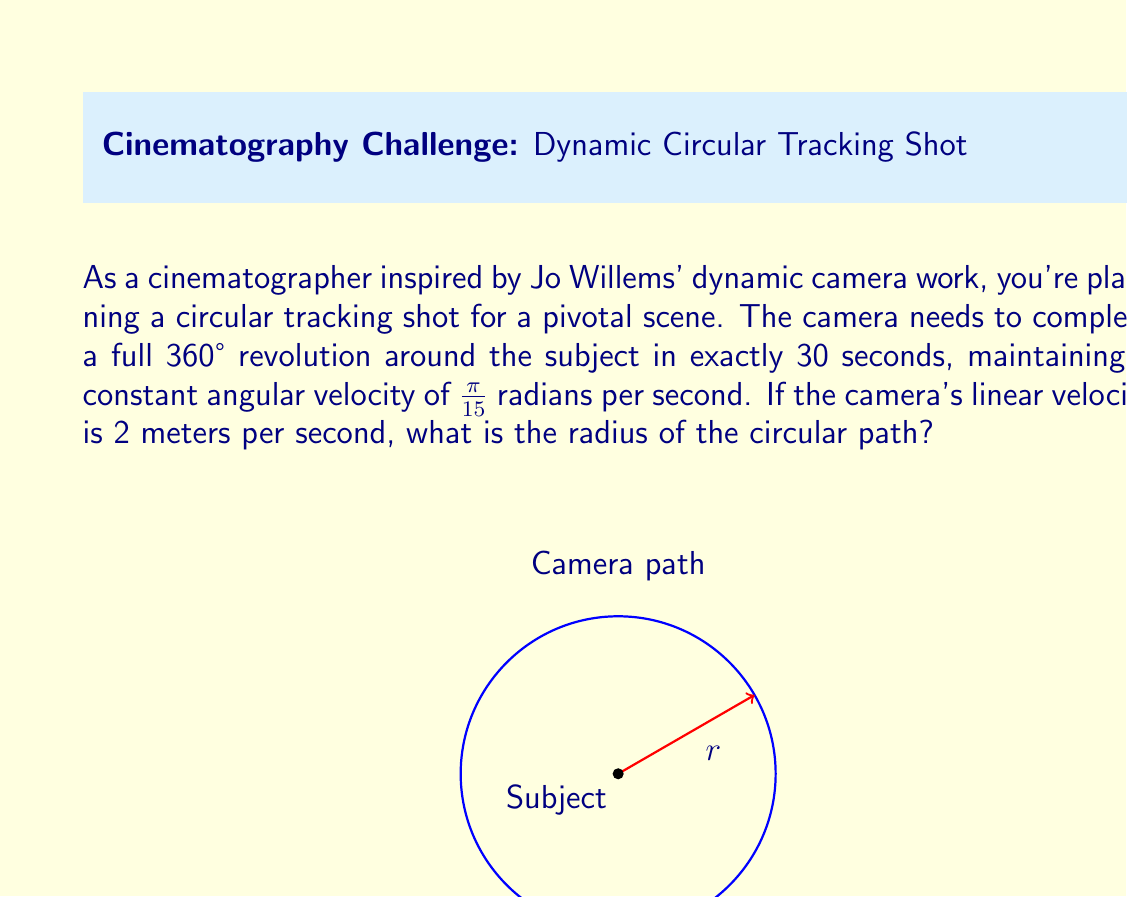Show me your answer to this math problem. Let's approach this step-by-step:

1) First, recall the relationship between angular velocity ($\omega$), linear velocity ($v$), and radius ($r$):

   $v = \omega r$

2) We're given:
   - Angular velocity: $\omega = \frac{\pi}{15}$ rad/s
   - Linear velocity: $v = 2$ m/s

3) Substituting these into the equation:

   $2 = \frac{\pi}{15} r$

4) To solve for $r$, we multiply both sides by $\frac{15}{\pi}$:

   $2 \cdot \frac{15}{\pi} = r$

5) Simplify:

   $r = \frac{30}{\pi}$ meters

6) To verify, we can check if this completes a full revolution in 30 seconds:
   - Circumference = $2\pi r = 2\pi \cdot \frac{30}{\pi} = 60$ meters
   - Time to complete = $60 \text{ m} \div 2 \text{ m/s} = 30$ seconds

Thus, the radius of $\frac{30}{\pi}$ meters satisfies all conditions.
Answer: $\frac{30}{\pi}$ meters 